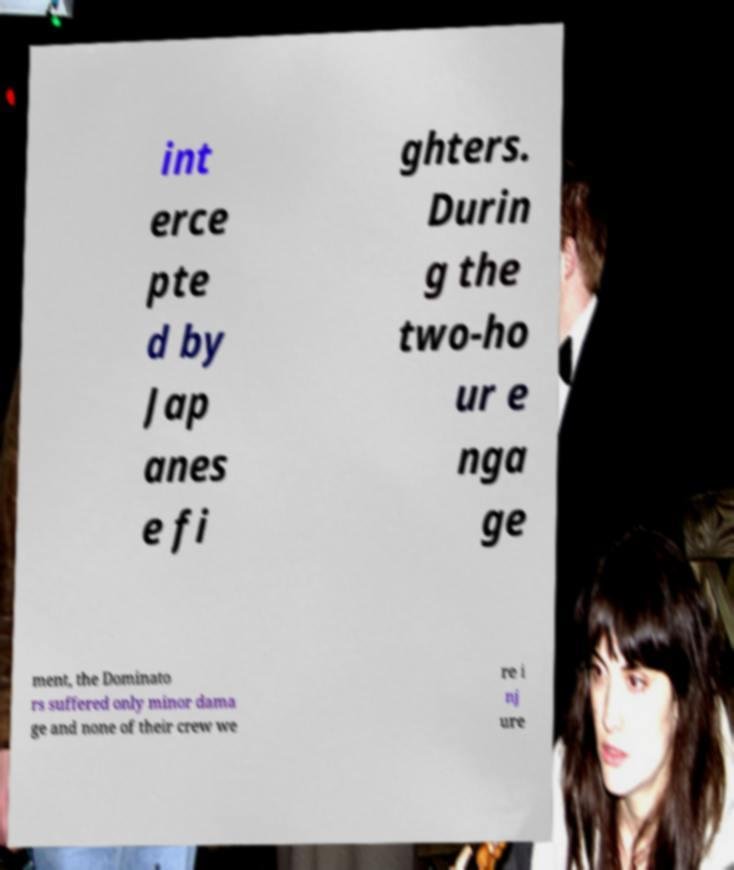Could you assist in decoding the text presented in this image and type it out clearly? int erce pte d by Jap anes e fi ghters. Durin g the two-ho ur e nga ge ment, the Dominato rs suffered only minor dama ge and none of their crew we re i nj ure 